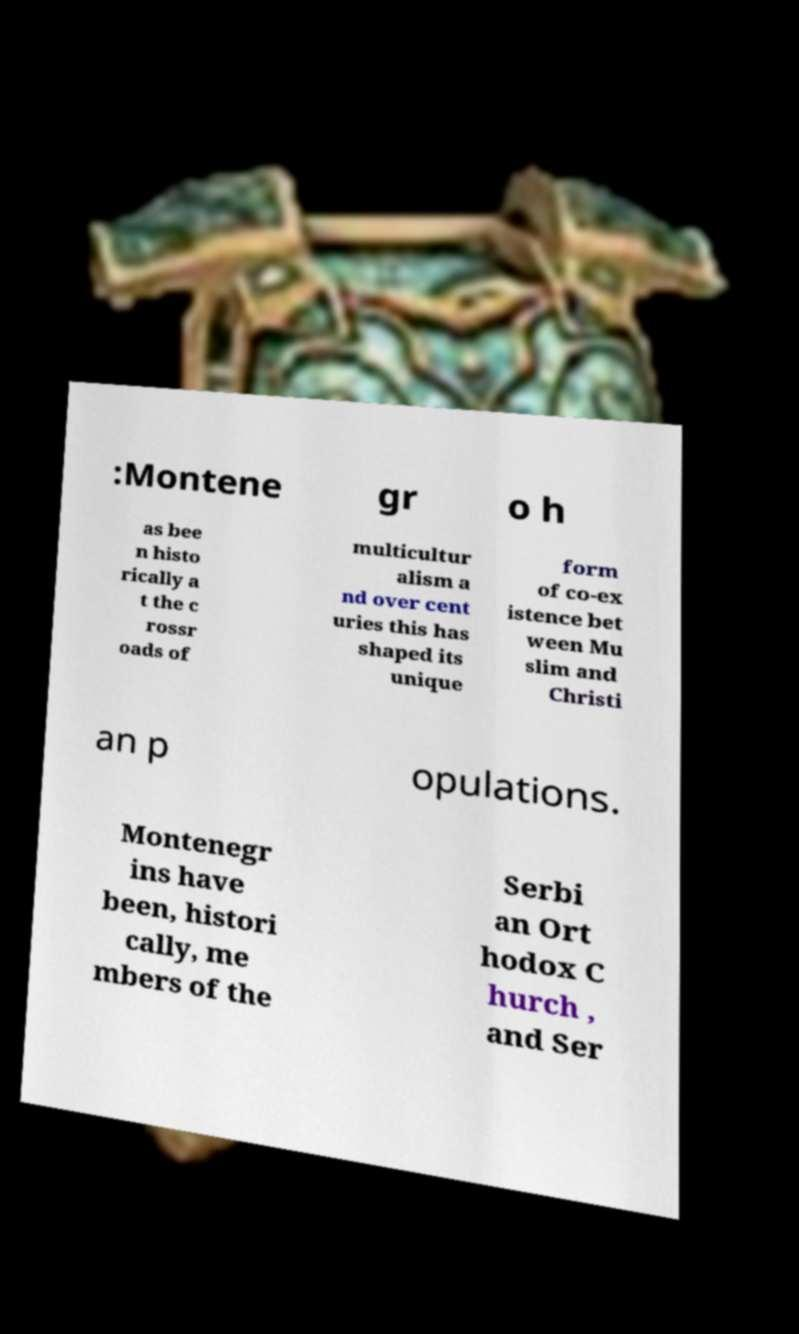Can you read and provide the text displayed in the image?This photo seems to have some interesting text. Can you extract and type it out for me? :Montene gr o h as bee n histo rically a t the c rossr oads of multicultur alism a nd over cent uries this has shaped its unique form of co-ex istence bet ween Mu slim and Christi an p opulations. Montenegr ins have been, histori cally, me mbers of the Serbi an Ort hodox C hurch , and Ser 